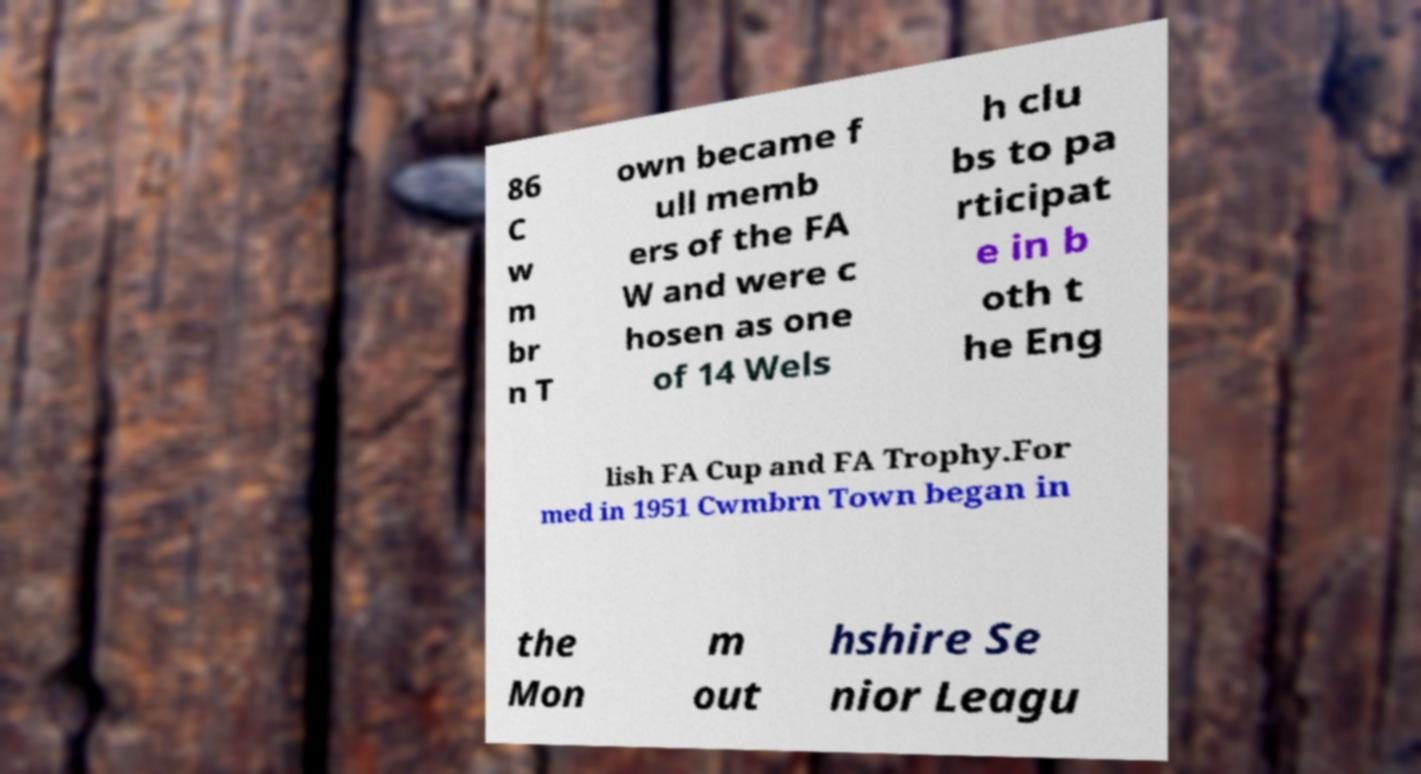What messages or text are displayed in this image? I need them in a readable, typed format. 86 C w m br n T own became f ull memb ers of the FA W and were c hosen as one of 14 Wels h clu bs to pa rticipat e in b oth t he Eng lish FA Cup and FA Trophy.For med in 1951 Cwmbrn Town began in the Mon m out hshire Se nior Leagu 